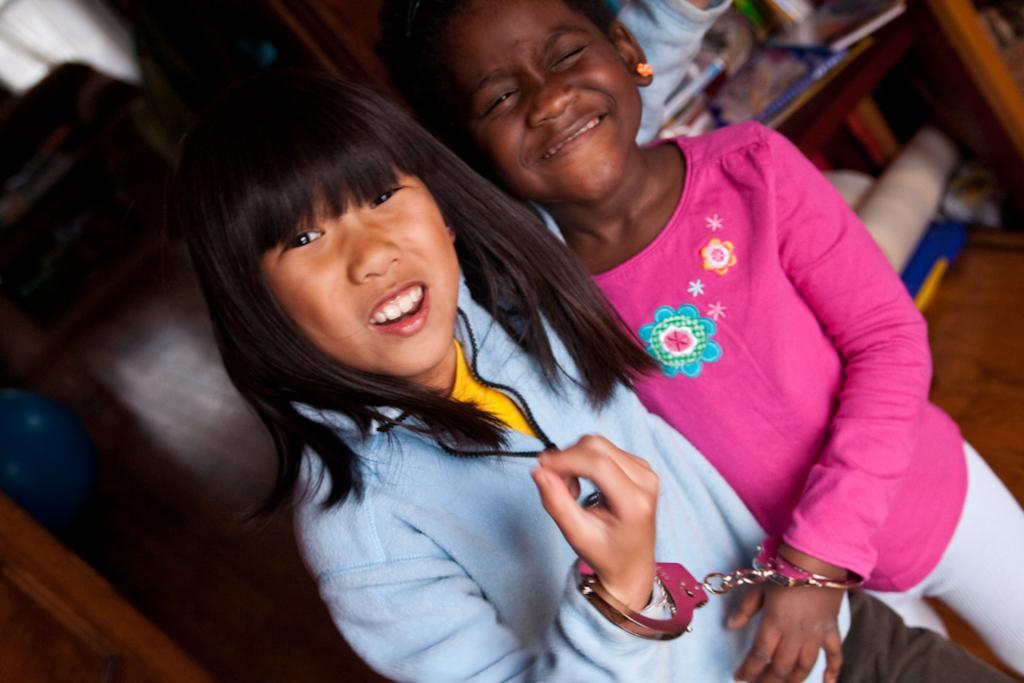Could you give a brief overview of what you see in this image? Here I can see two girls standing, smiling and looking at the picture. To their hands, I can see the handcuffs. In the background there is a table on which few books and some other objects are placed. Under the table there are some objects. On the left side there is a wooden object. 